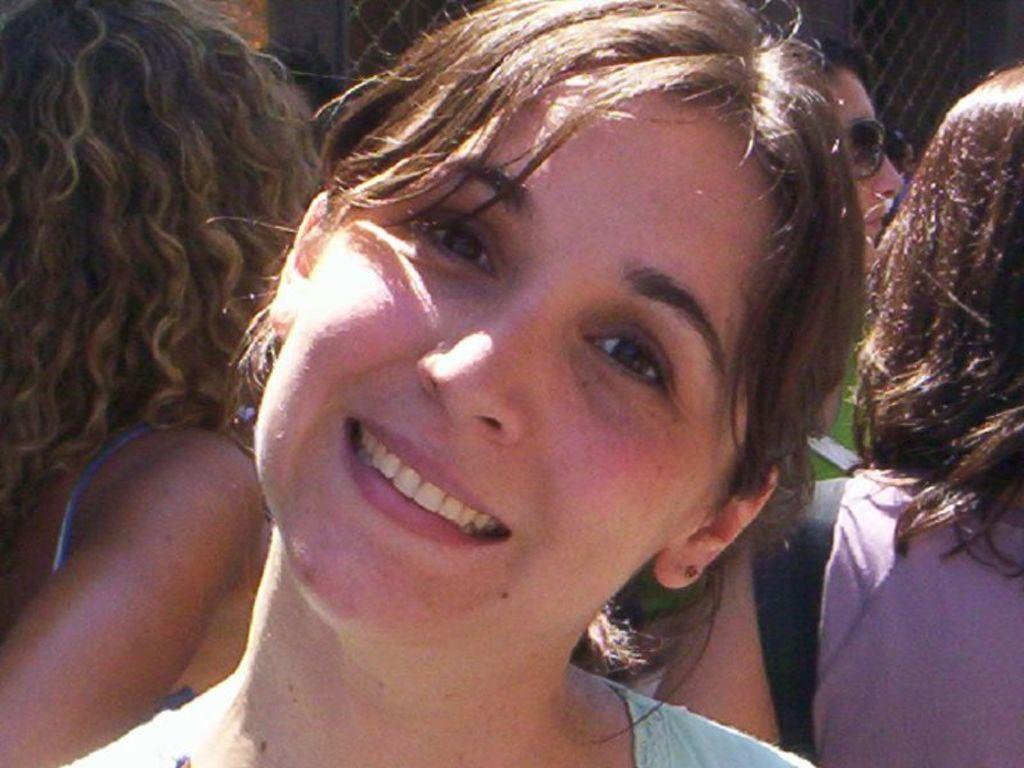Who is the main subject in the image? There is a lady in the center of the image. What is the lady doing in the image? The lady is smiling. Can you describe the background of the image? There are persons visible in the background of the image. What is the object in the top right corner of the image? There is a mesh in the top right corner of the image. What type of soup is being served to the lady in the image? There is no soup present in the image. Can you tell me how many turkeys are visible in the image? There are no turkeys visible in the image; the image features a lady and some persons in the background. 